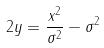Convert formula to latex. <formula><loc_0><loc_0><loc_500><loc_500>2 y = \frac { x ^ { 2 } } { \sigma ^ { 2 } } - \sigma ^ { 2 }</formula> 